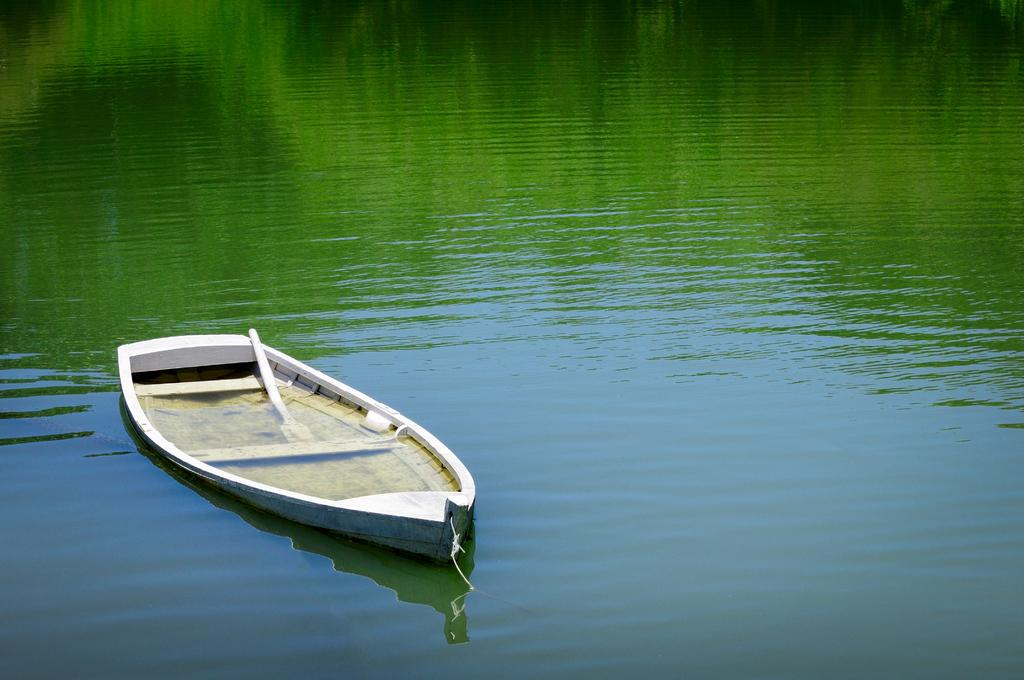What is the main subject of the image? The main subject of the image is a boat. What feature does the boat have? The boat has a paddle. Where is the boat located in the image? The boat is on the water. What type of bone can be seen in the boat in the image? There is no bone present in the boat or the image. What nation is represented by the boat in the image? The image does not provide any information about the nation associated with the boat. 